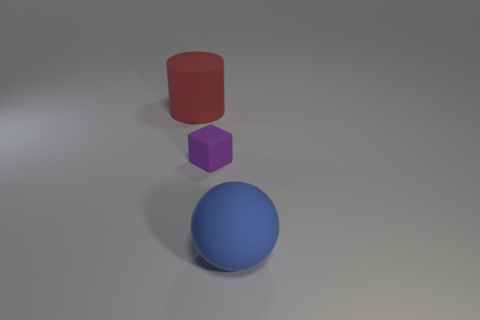Is there anything else that has the same size as the rubber cube?
Your answer should be compact. No. How many objects are both left of the big blue matte sphere and right of the large rubber cylinder?
Make the answer very short. 1. There is a large rubber object that is in front of the large object that is on the left side of the large blue matte ball; what number of big red objects are left of it?
Provide a succinct answer. 1. What shape is the tiny purple matte object?
Offer a very short reply. Cube. How many large cylinders have the same material as the small block?
Ensure brevity in your answer.  1. There is a tiny cube that is the same material as the big red cylinder; what color is it?
Provide a succinct answer. Purple. Does the purple block have the same size as the thing right of the small thing?
Keep it short and to the point. No. How many things are either small purple matte cubes or large cylinders?
Offer a terse response. 2. There is another matte thing that is the same size as the blue thing; what is its shape?
Give a very brief answer. Cylinder. What number of things are either matte objects that are in front of the tiny purple matte object or big matte objects on the right side of the red rubber cylinder?
Provide a short and direct response. 1. 